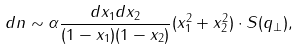<formula> <loc_0><loc_0><loc_500><loc_500>d n \sim \alpha \frac { d x _ { 1 } d x _ { 2 } } { ( 1 - x _ { 1 } ) ( 1 - x _ { 2 } ) } ( x _ { 1 } ^ { 2 } + x _ { 2 } ^ { 2 } ) \cdot S ( q _ { \perp } ) ,</formula> 